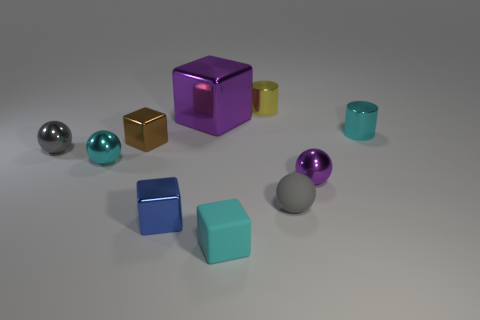There is a thing that is both left of the large purple metal block and behind the small gray metal object; what is its shape? cube 